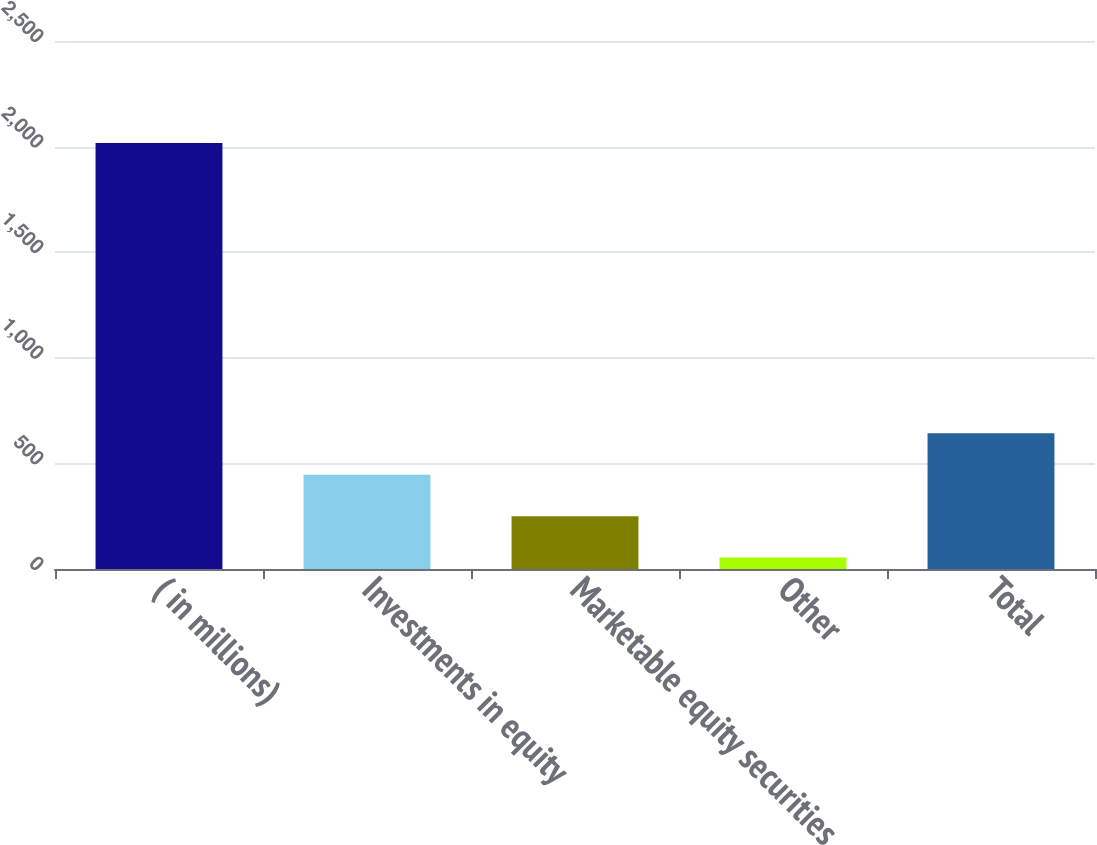<chart> <loc_0><loc_0><loc_500><loc_500><bar_chart><fcel>( in millions)<fcel>Investments in equity<fcel>Marketable equity securities<fcel>Other<fcel>Total<nl><fcel>2017<fcel>446.6<fcel>250.3<fcel>54<fcel>642.9<nl></chart> 